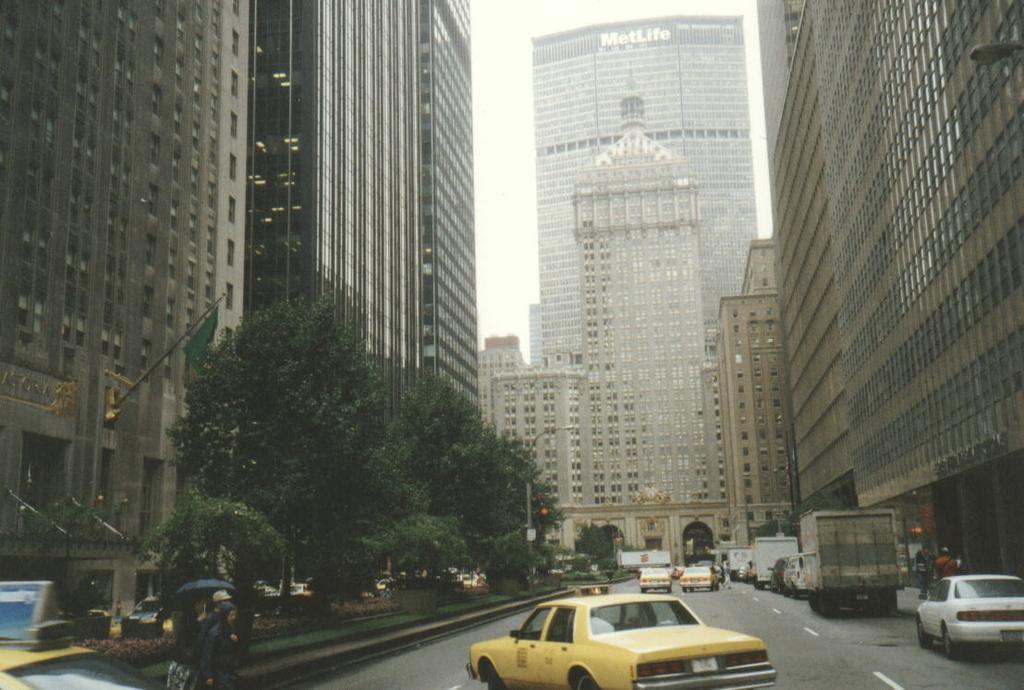<image>
Summarize the visual content of the image. The yellow taxi cab with taxi written on the side waits in the street for a fare. 